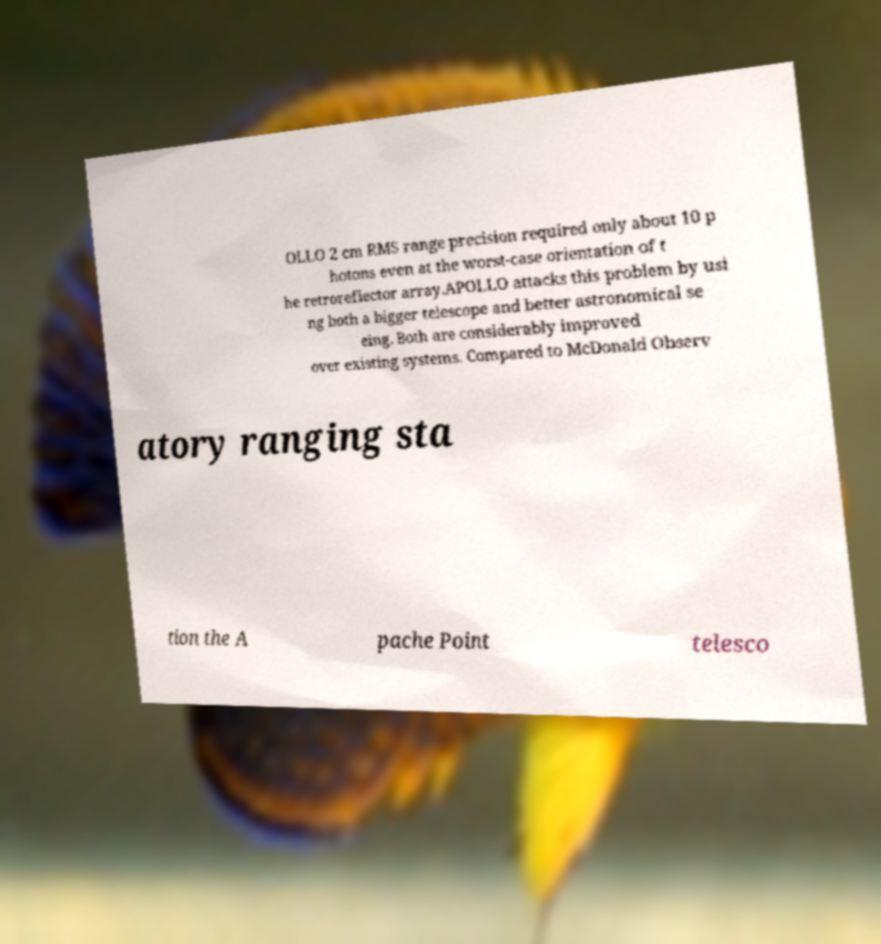Please identify and transcribe the text found in this image. OLLO 2 cm RMS range precision required only about 10 p hotons even at the worst-case orientation of t he retroreflector array.APOLLO attacks this problem by usi ng both a bigger telescope and better astronomical se eing. Both are considerably improved over existing systems. Compared to McDonald Observ atory ranging sta tion the A pache Point telesco 